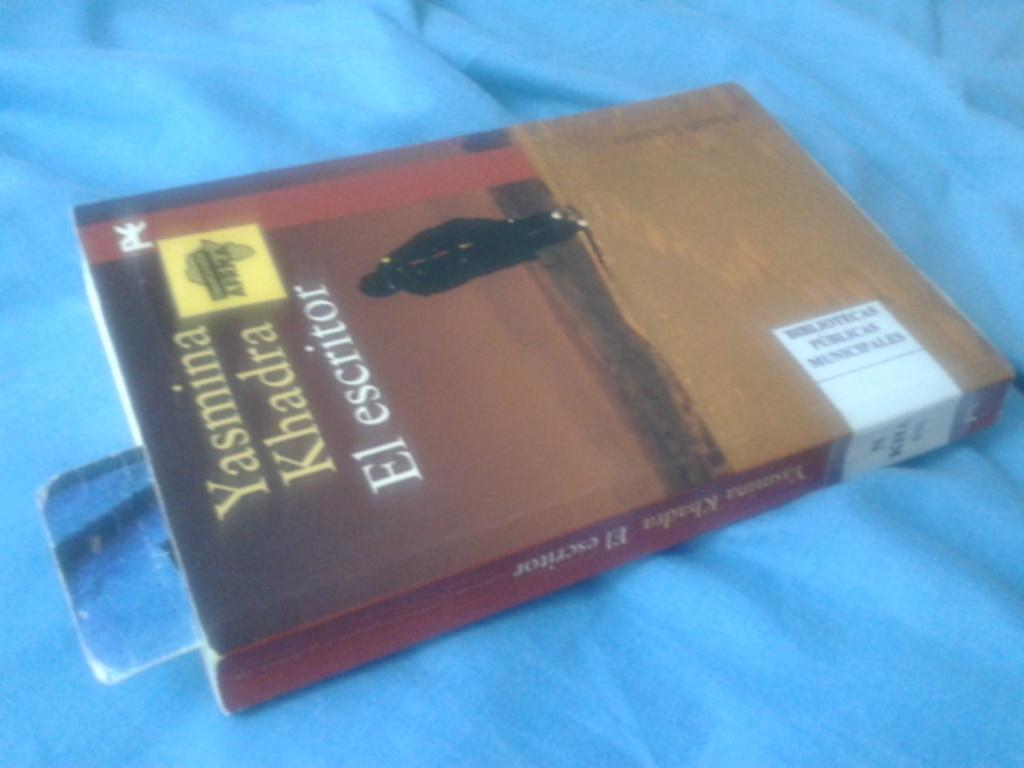<image>
Render a clear and concise summary of the photo. a brown book that says el escritor on it 